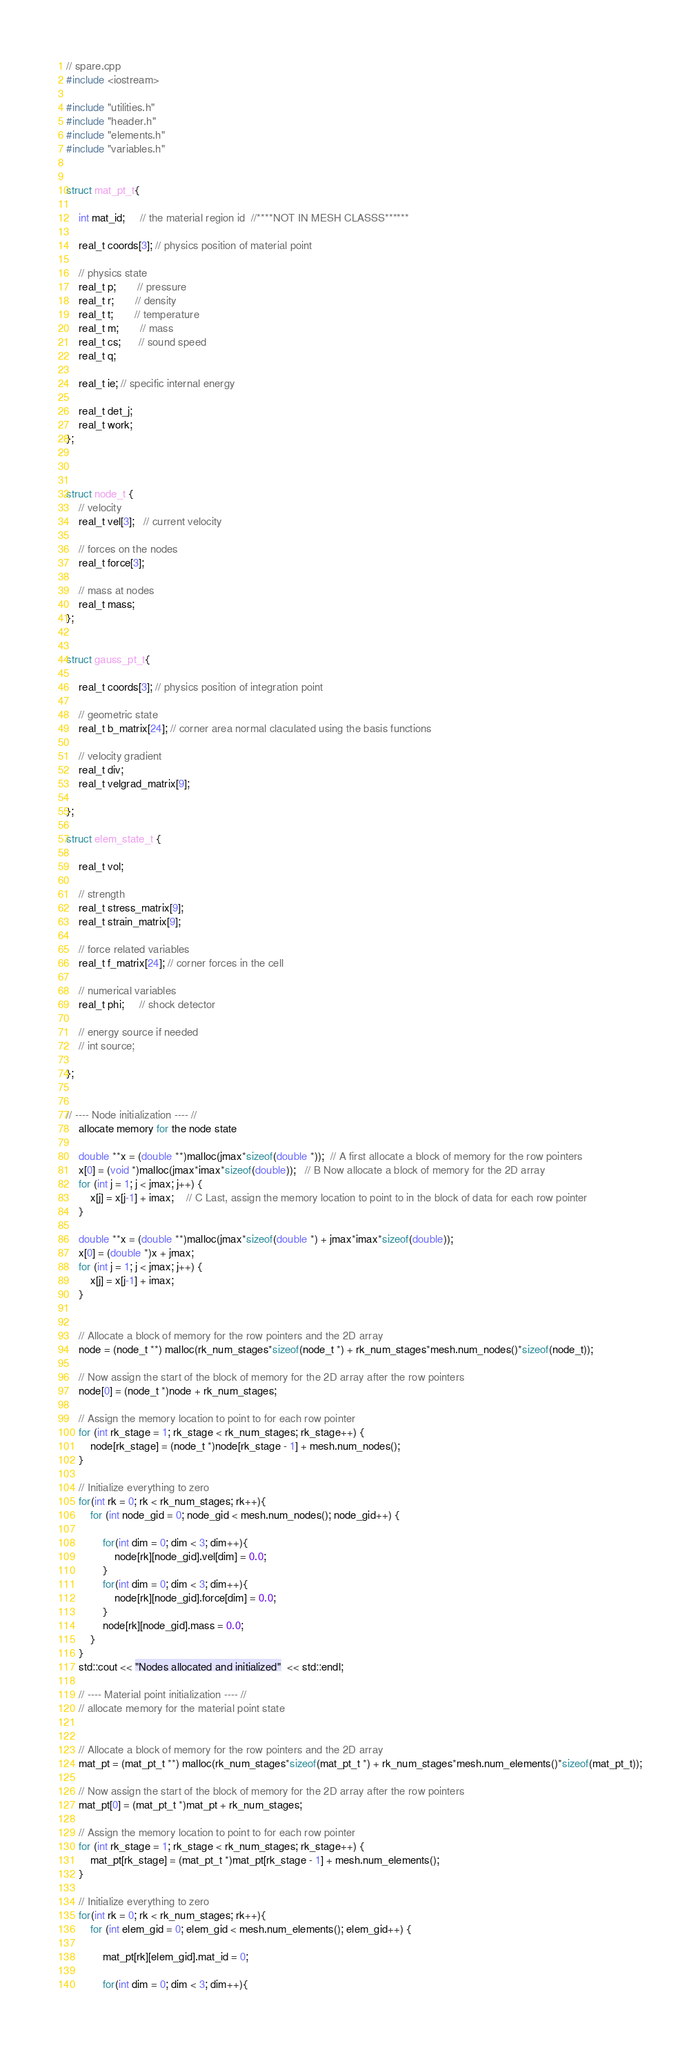<code> <loc_0><loc_0><loc_500><loc_500><_C++_>// spare.cpp
#include <iostream>

#include "utilities.h"
#include "header.h"
#include "elements.h"
#include "variables.h"


struct mat_pt_t{

    int mat_id;     // the material region id  //****NOT IN MESH CLASSS******

    real_t coords[3]; // physics position of material point

    // physics state
    real_t p;       // pressure
    real_t r;       // density
    real_t t;       // temperature
    real_t m;       // mass
    real_t cs;      // sound speed
    real_t q;

    real_t ie; // specific internal energy

    real_t det_j;
    real_t work;
};



struct node_t {
    // velocity 
    real_t vel[3];   // current velocity
    
    // forces on the nodes
    real_t force[3];

    // mass at nodes
    real_t mass;
};


struct gauss_pt_t{

    real_t coords[3]; // physics position of integration point

    // geometric state
    real_t b_matrix[24]; // corner area normal claculated using the basis functions

    // velocity gradient
    real_t div;
    real_t velgrad_matrix[9];

};

struct elem_state_t {

    real_t vol; 

    // strength
    real_t stress_matrix[9];
    real_t strain_matrix[9];
    
    // force related variables
    real_t f_matrix[24]; // corner forces in the cell
    
    // numerical variables
    real_t phi;     // shock detector
    
    // energy source if needed
    // int source;

};


// ---- Node initialization ---- //
    allocate memory for the node state

    double **x = (double **)malloc(jmax*sizeof(double *));  // A first allocate a block of memory for the row pointers
    x[0] = (void *)malloc(jmax*imax*sizeof(double));   // B Now allocate a block of memory for the 2D array
    for (int j = 1; j < jmax; j++) {
        x[j] = x[j-1] + imax;    // C Last, assign the memory location to point to in the block of data for each row pointer
    }

    double **x = (double **)malloc(jmax*sizeof(double *) + jmax*imax*sizeof(double));  
    x[0] = (double *)x + jmax;  
    for (int j = 1; j < jmax; j++) {
        x[j] = x[j-1] + imax;    
    }


    // Allocate a block of memory for the row pointers and the 2D array
    node = (node_t **) malloc(rk_num_stages*sizeof(node_t *) + rk_num_stages*mesh.num_nodes()*sizeof(node_t));

    // Now assign the start of the block of memory for the 2D array after the row pointers
    node[0] = (node_t *)node + rk_num_stages;

    // Assign the memory location to point to for each row pointer
    for (int rk_stage = 1; rk_stage < rk_num_stages; rk_stage++) {
        node[rk_stage] = (node_t *)node[rk_stage - 1] + mesh.num_nodes(); 
    }

    // Initialize everything to zero
    for(int rk = 0; rk < rk_num_stages; rk++){
        for (int node_gid = 0; node_gid < mesh.num_nodes(); node_gid++) {

            for(int dim = 0; dim < 3; dim++){
                node[rk][node_gid].vel[dim] = 0.0;
            }
            for(int dim = 0; dim < 3; dim++){
                node[rk][node_gid].force[dim] = 0.0;
            }
            node[rk][node_gid].mass = 0.0;
        }
    }
    std::cout << "Nodes allocated and initialized"  << std::endl;

    // ---- Material point initialization ---- //
    // allocate memory for the material point state
    

    // Allocate a block of memory for the row pointers and the 2D array
    mat_pt = (mat_pt_t **) malloc(rk_num_stages*sizeof(mat_pt_t *) + rk_num_stages*mesh.num_elements()*sizeof(mat_pt_t));

    // Now assign the start of the block of memory for the 2D array after the row pointers
    mat_pt[0] = (mat_pt_t *)mat_pt + rk_num_stages;

    // Assign the memory location to point to for each row pointer
    for (int rk_stage = 1; rk_stage < rk_num_stages; rk_stage++) {
        mat_pt[rk_stage] = (mat_pt_t *)mat_pt[rk_stage - 1] + mesh.num_elements(); 
    }

    // Initialize everything to zero
    for(int rk = 0; rk < rk_num_stages; rk++){
        for (int elem_gid = 0; elem_gid < mesh.num_elements(); elem_gid++) {

            mat_pt[rk][elem_gid].mat_id = 0;

            for(int dim = 0; dim < 3; dim++){</code> 